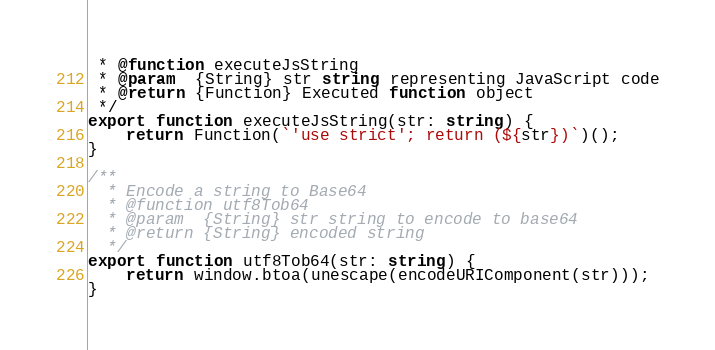Convert code to text. <code><loc_0><loc_0><loc_500><loc_500><_TypeScript_> * @function executeJsString
 * @param  {String} str string representing JavaScript code
 * @return {Function} Executed function object
 */
export function executeJsString(str: string) {
    return Function(`'use strict'; return (${str})`)();
}

/**
  * Encode a string to Base64
  * @function utf8Tob64
  * @param  {String} str string to encode to base64
  * @return {String} encoded string
  */
export function utf8Tob64(str: string) {
    return window.btoa(unescape(encodeURIComponent(str)));
}</code> 